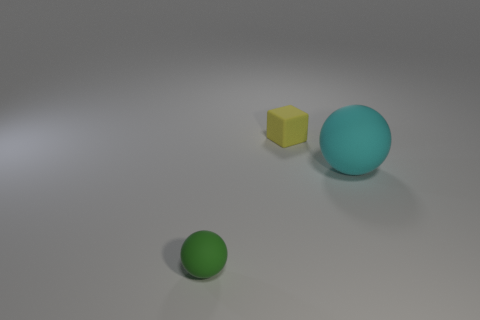Is there any indication of movement or activity in the image? The image appears static, with no explicit indication of movement. The objects are resting on a flat surface, and there's no blur or other effects that would suggest recent activity or motion. 